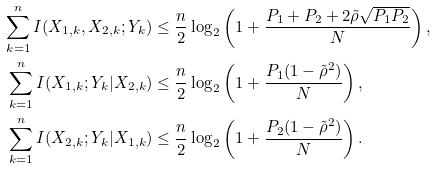Convert formula to latex. <formula><loc_0><loc_0><loc_500><loc_500>\sum _ { k = 1 } ^ { n } I ( X _ { 1 , k } , X _ { 2 , k } ; Y _ { k } ) & \leq \frac { n } { 2 } \log _ { 2 } \left ( 1 + \frac { P _ { 1 } + P _ { 2 } + 2 \tilde { \rho } \sqrt { P _ { 1 } P _ { 2 } } } { N } \right ) , \\ \sum _ { k = 1 } ^ { n } I ( X _ { 1 , k } ; Y _ { k } | X _ { 2 , k } ) & \leq \frac { n } { 2 } \log _ { 2 } \left ( 1 + \frac { P _ { 1 } ( 1 - \tilde { \rho } ^ { 2 } ) } { N } \right ) , \\ \sum _ { k = 1 } ^ { n } I ( X _ { 2 , k } ; Y _ { k } | X _ { 1 , k } ) & \leq \frac { n } { 2 } \log _ { 2 } \left ( 1 + \frac { P _ { 2 } ( 1 - \tilde { \rho } ^ { 2 } ) } { N } \right ) .</formula> 